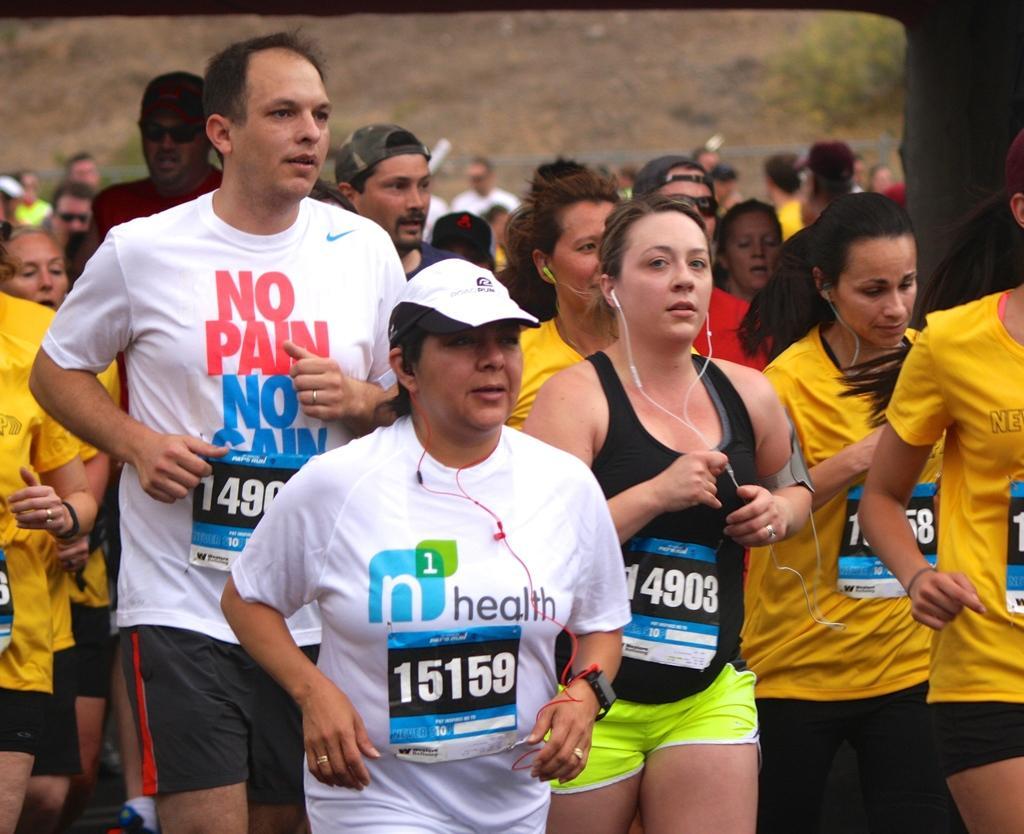Can you describe this image briefly? In this image there are a group of persons running, there are wires, there is an object towards the right of the image, there is a plant on the ground towards the top of the image. 